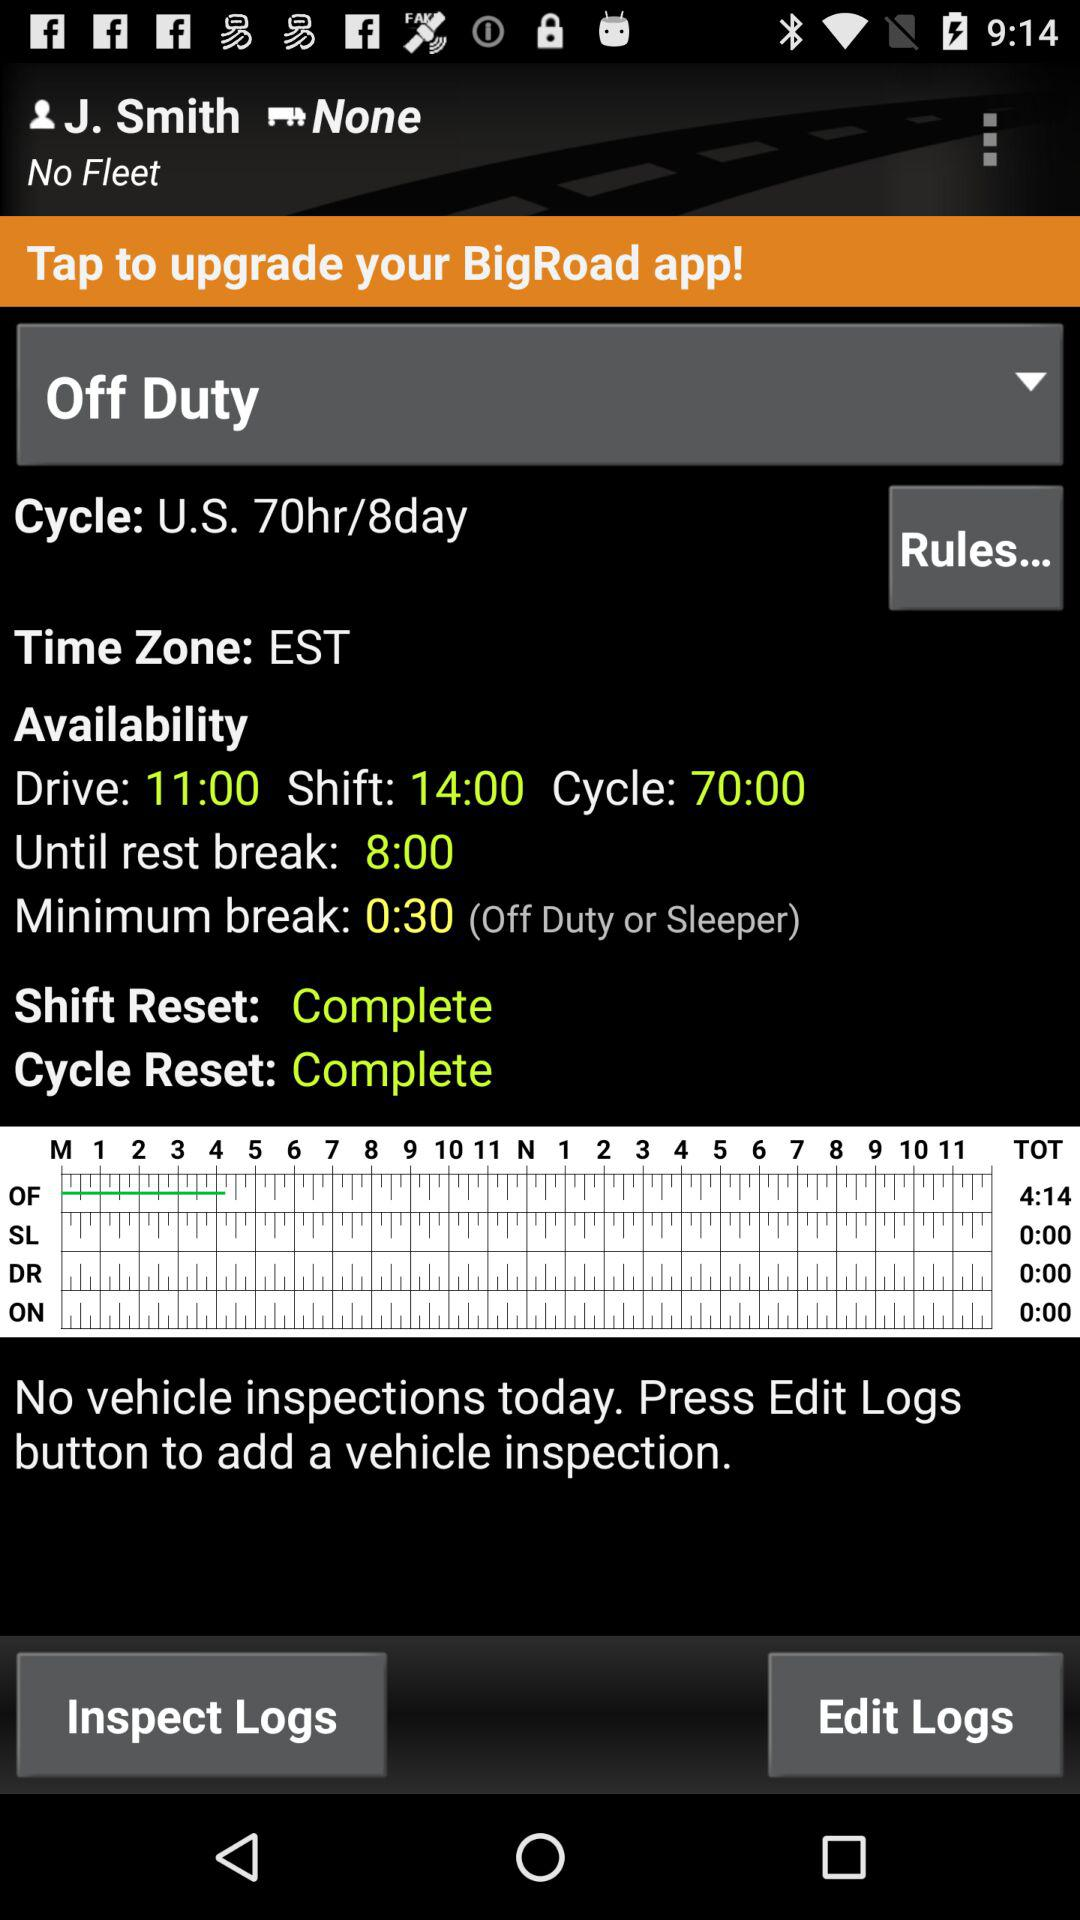What time zone is mentioned? The mentioned time zone is EST. 